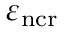<formula> <loc_0><loc_0><loc_500><loc_500>\varepsilon _ { n { c r } }</formula> 